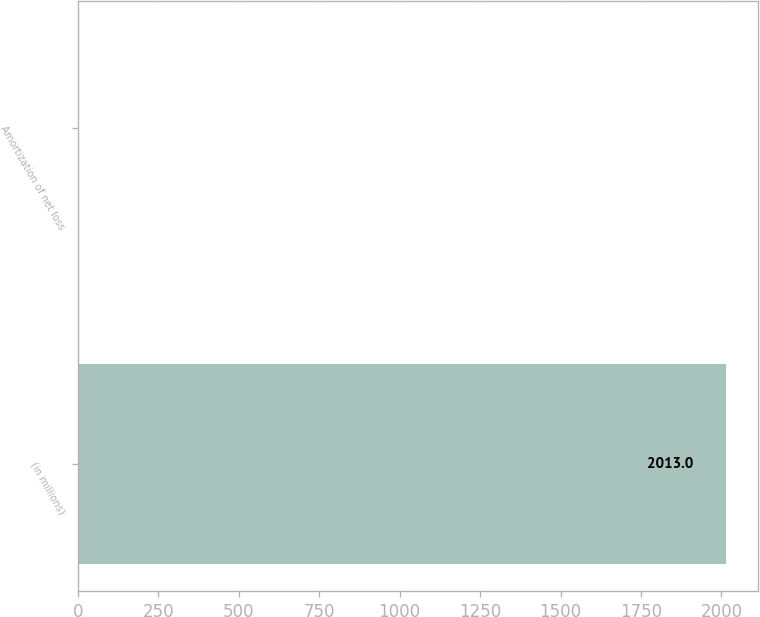<chart> <loc_0><loc_0><loc_500><loc_500><bar_chart><fcel>(in millions)<fcel>Amortization of net loss<nl><fcel>2013<fcel>2<nl></chart> 